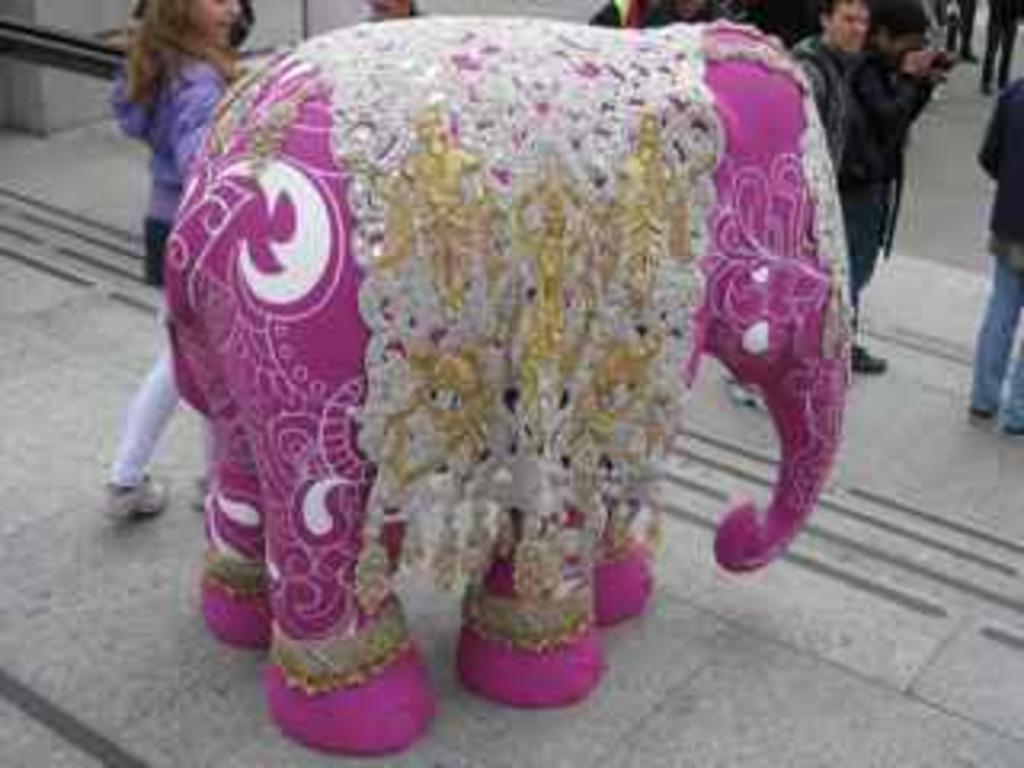How would you summarize this image in a sentence or two? In this picture I can observe costume of an elephant which is in pink color. I can observe some people in the background. 